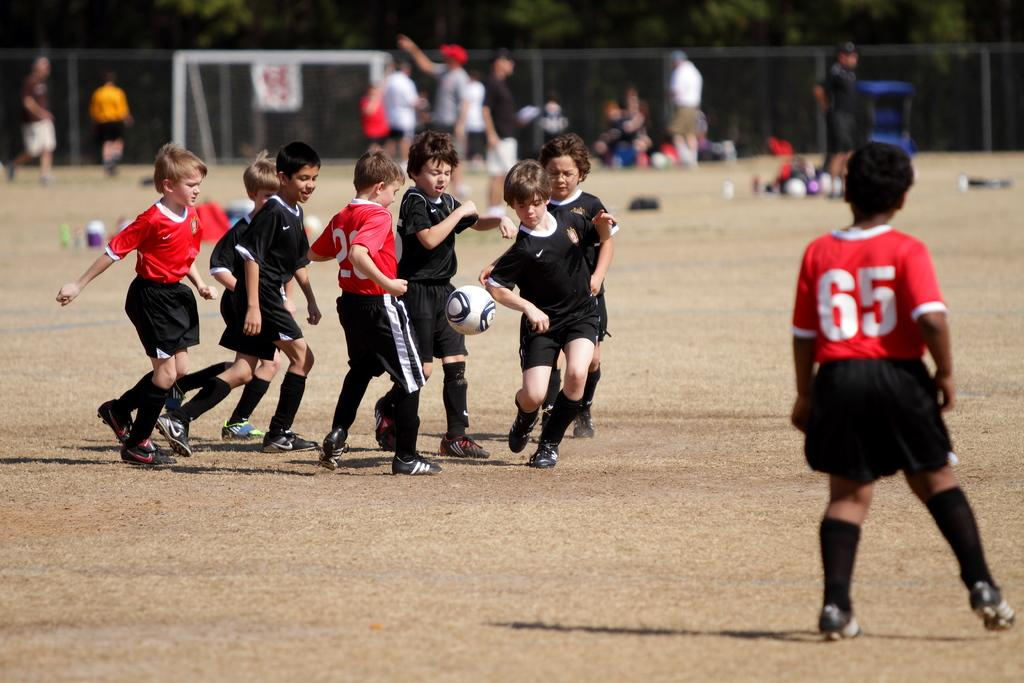What are the children in the image doing? The children are playing with a football. Where are the children playing? The children are playing on the ground. Can you describe the background of the image? The background of the image is blurred. What else can be seen in the background? There are many people and a football post in the background, as well as trees. What type of feast is being prepared in the background of the image? There is no indication of a feast being prepared in the image; it primarily focuses on the children playing with a football. 